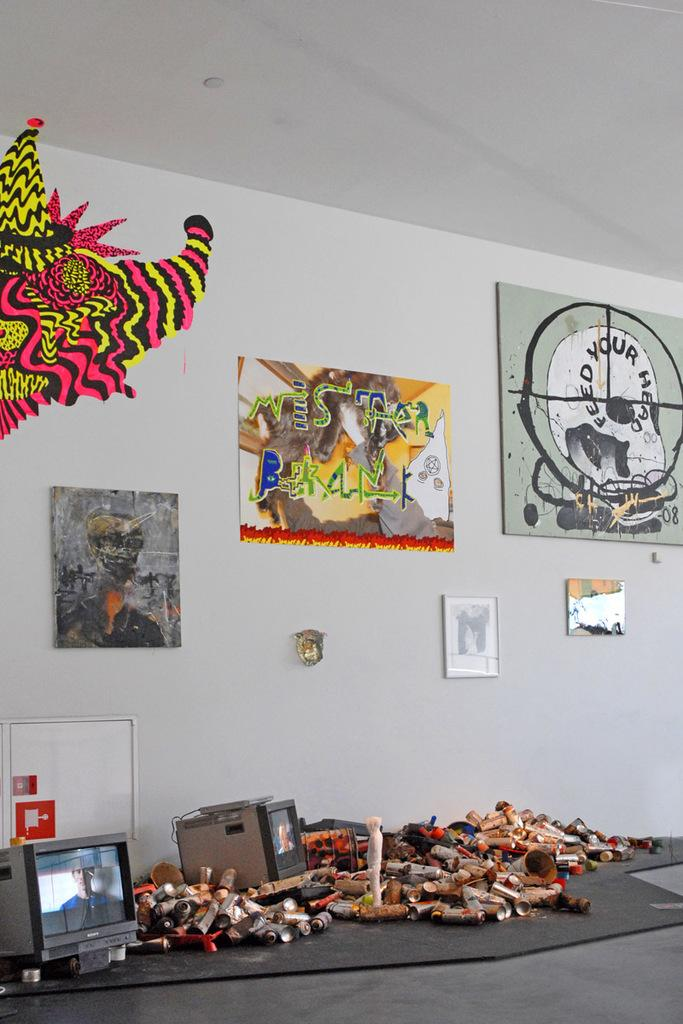What objects are located at the bottom of the image? There are televisions and tins at the bottom of the image. What is placed on the floor in the image? There is a statue placed on the floor. What can be seen on the wall in the image? There are photo frames and a decorative item placed on the wall. What type of trucks are depicted in the photo frames on the wall? There are no trucks present in the image, as the photo frames contain unspecified content. What industry is represented by the statue placed on the floor? The statue does not represent any specific industry; it is a decorative item. 